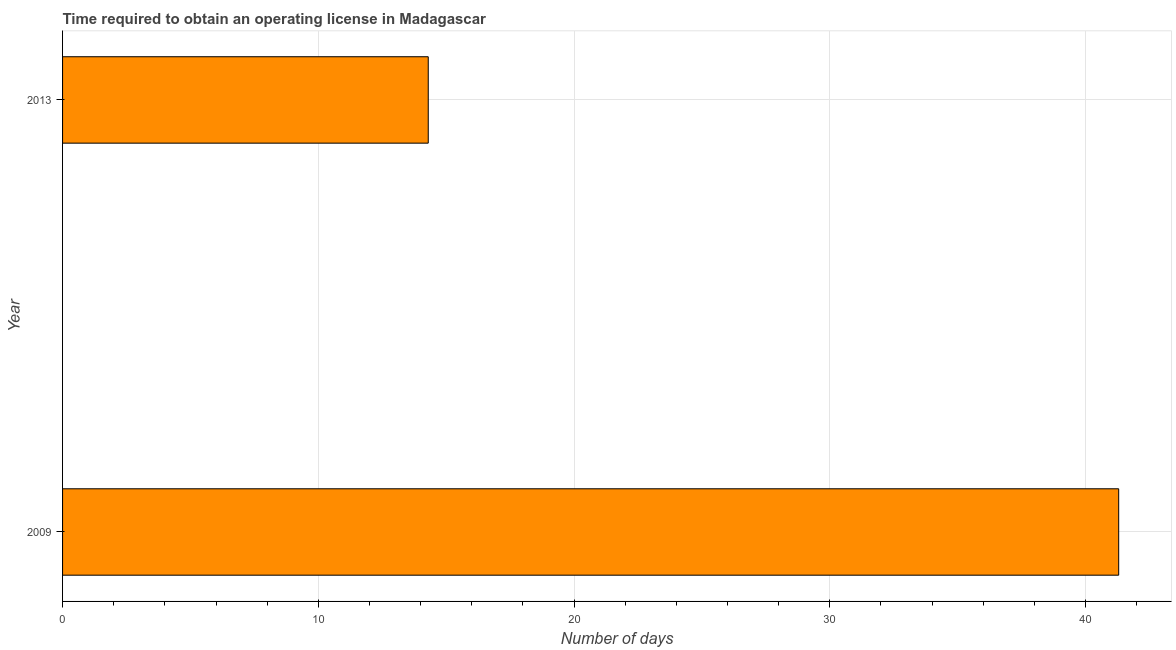Does the graph contain any zero values?
Your answer should be very brief. No. Does the graph contain grids?
Your response must be concise. Yes. What is the title of the graph?
Make the answer very short. Time required to obtain an operating license in Madagascar. What is the label or title of the X-axis?
Provide a succinct answer. Number of days. What is the label or title of the Y-axis?
Provide a succinct answer. Year. What is the number of days to obtain operating license in 2009?
Make the answer very short. 41.3. Across all years, what is the maximum number of days to obtain operating license?
Offer a very short reply. 41.3. In which year was the number of days to obtain operating license maximum?
Ensure brevity in your answer.  2009. What is the sum of the number of days to obtain operating license?
Your answer should be very brief. 55.6. What is the average number of days to obtain operating license per year?
Offer a very short reply. 27.8. What is the median number of days to obtain operating license?
Provide a short and direct response. 27.8. Do a majority of the years between 2009 and 2013 (inclusive) have number of days to obtain operating license greater than 34 days?
Give a very brief answer. No. What is the ratio of the number of days to obtain operating license in 2009 to that in 2013?
Provide a short and direct response. 2.89. Is the number of days to obtain operating license in 2009 less than that in 2013?
Ensure brevity in your answer.  No. Are all the bars in the graph horizontal?
Your answer should be very brief. Yes. What is the difference between two consecutive major ticks on the X-axis?
Make the answer very short. 10. What is the Number of days of 2009?
Make the answer very short. 41.3. What is the difference between the Number of days in 2009 and 2013?
Keep it short and to the point. 27. What is the ratio of the Number of days in 2009 to that in 2013?
Your answer should be very brief. 2.89. 